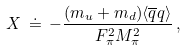<formula> <loc_0><loc_0><loc_500><loc_500>X \, \doteq \, - \frac { ( m _ { u } + m _ { d } ) \langle { \overline { q } } q \rangle } { F _ { \pi } ^ { 2 } M _ { \pi } ^ { 2 } } \, ,</formula> 